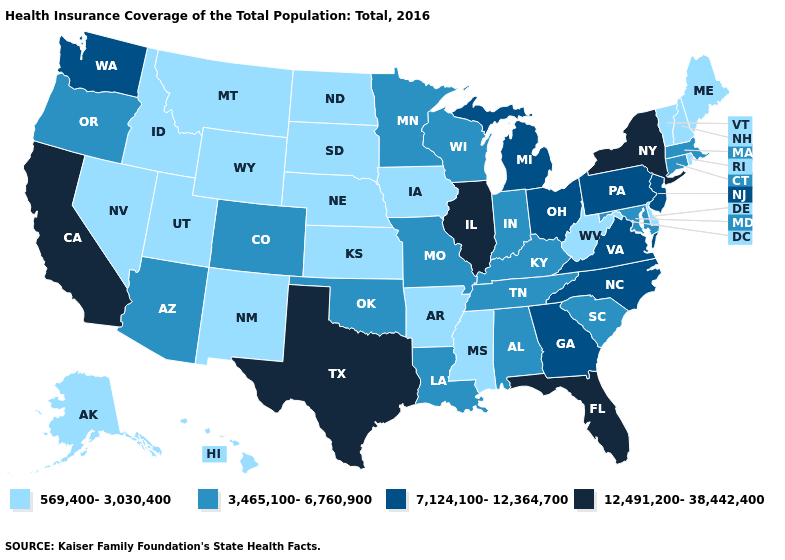What is the value of Massachusetts?
Write a very short answer. 3,465,100-6,760,900. What is the highest value in the Northeast ?
Concise answer only. 12,491,200-38,442,400. Among the states that border Tennessee , does Arkansas have the lowest value?
Be succinct. Yes. Name the states that have a value in the range 569,400-3,030,400?
Quick response, please. Alaska, Arkansas, Delaware, Hawaii, Idaho, Iowa, Kansas, Maine, Mississippi, Montana, Nebraska, Nevada, New Hampshire, New Mexico, North Dakota, Rhode Island, South Dakota, Utah, Vermont, West Virginia, Wyoming. Name the states that have a value in the range 569,400-3,030,400?
Quick response, please. Alaska, Arkansas, Delaware, Hawaii, Idaho, Iowa, Kansas, Maine, Mississippi, Montana, Nebraska, Nevada, New Hampshire, New Mexico, North Dakota, Rhode Island, South Dakota, Utah, Vermont, West Virginia, Wyoming. What is the value of California?
Give a very brief answer. 12,491,200-38,442,400. Does Texas have the highest value in the USA?
Concise answer only. Yes. How many symbols are there in the legend?
Quick response, please. 4. Does the first symbol in the legend represent the smallest category?
Write a very short answer. Yes. What is the value of Oregon?
Be succinct. 3,465,100-6,760,900. Does North Dakota have a higher value than Maine?
Keep it brief. No. Name the states that have a value in the range 12,491,200-38,442,400?
Write a very short answer. California, Florida, Illinois, New York, Texas. What is the value of Virginia?
Write a very short answer. 7,124,100-12,364,700. 